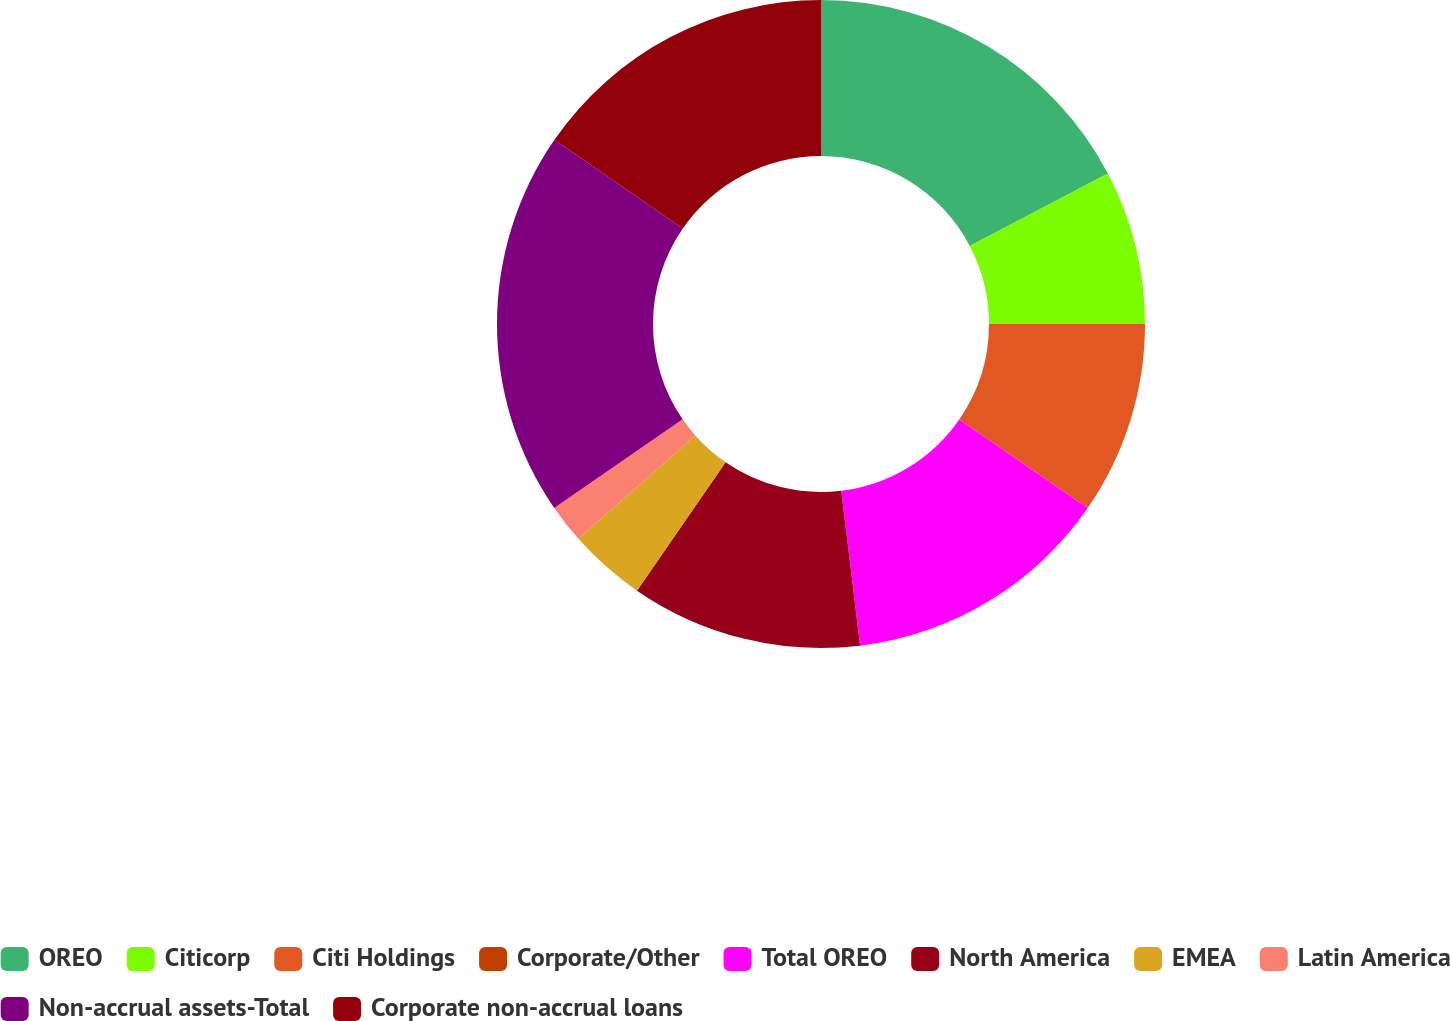Convert chart to OTSL. <chart><loc_0><loc_0><loc_500><loc_500><pie_chart><fcel>OREO<fcel>Citicorp<fcel>Citi Holdings<fcel>Corporate/Other<fcel>Total OREO<fcel>North America<fcel>EMEA<fcel>Latin America<fcel>Non-accrual assets-Total<fcel>Corporate non-accrual loans<nl><fcel>17.31%<fcel>7.69%<fcel>9.62%<fcel>0.0%<fcel>13.46%<fcel>11.54%<fcel>3.85%<fcel>1.93%<fcel>19.23%<fcel>15.38%<nl></chart> 